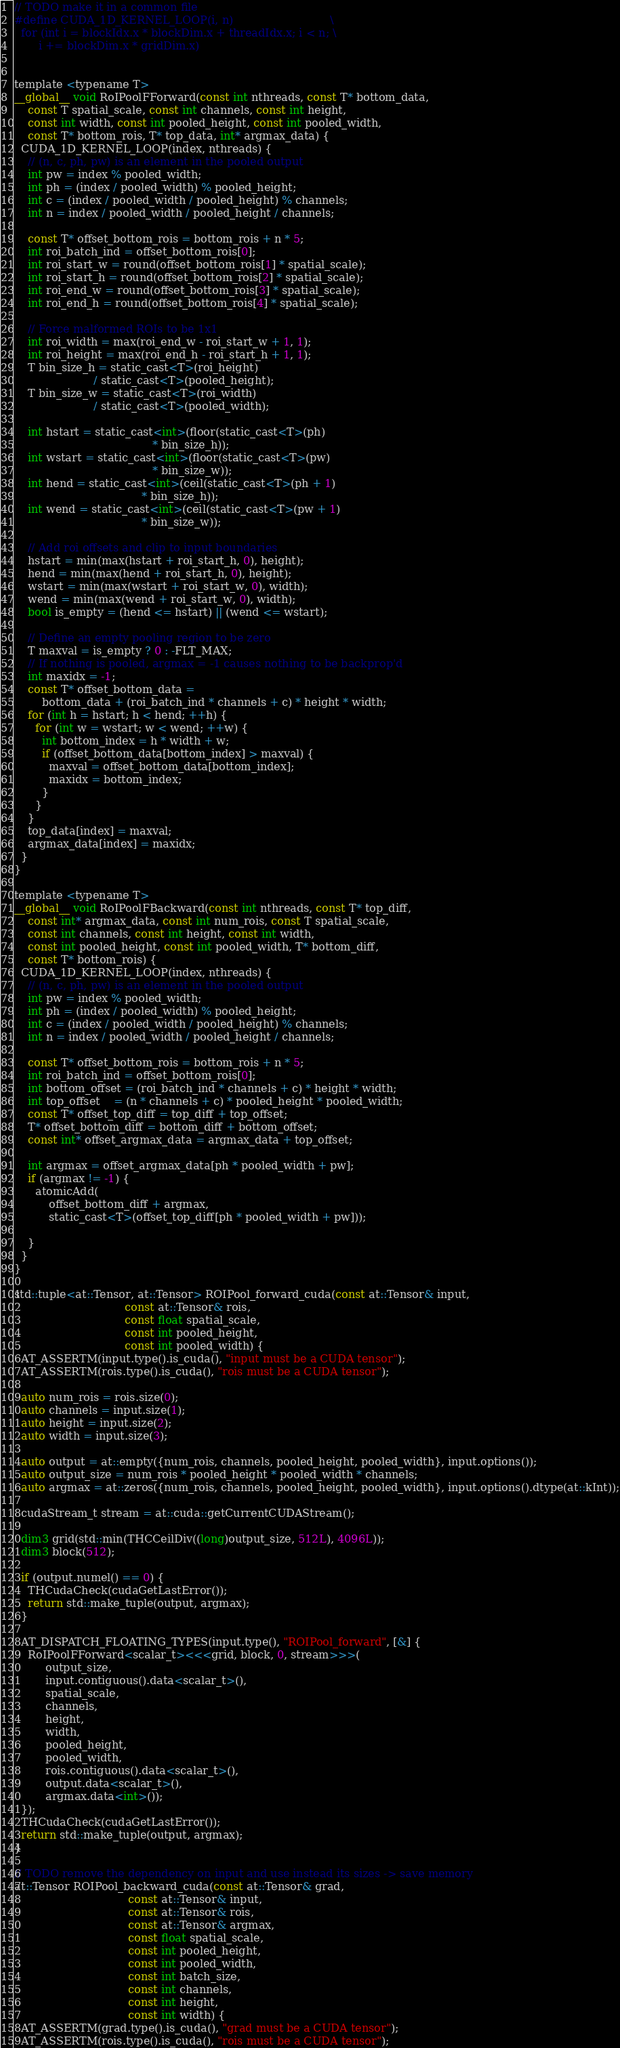Convert code to text. <code><loc_0><loc_0><loc_500><loc_500><_Cuda_>

// TODO make it in a common file
#define CUDA_1D_KERNEL_LOOP(i, n)                            \
  for (int i = blockIdx.x * blockDim.x + threadIdx.x; i < n; \
       i += blockDim.x * gridDim.x)


template <typename T>
__global__ void RoIPoolFForward(const int nthreads, const T* bottom_data,
    const T spatial_scale, const int channels, const int height,
    const int width, const int pooled_height, const int pooled_width,
    const T* bottom_rois, T* top_data, int* argmax_data) {
  CUDA_1D_KERNEL_LOOP(index, nthreads) {
    // (n, c, ph, pw) is an element in the pooled output
    int pw = index % pooled_width;
    int ph = (index / pooled_width) % pooled_height;
    int c = (index / pooled_width / pooled_height) % channels;
    int n = index / pooled_width / pooled_height / channels;

    const T* offset_bottom_rois = bottom_rois + n * 5;
    int roi_batch_ind = offset_bottom_rois[0];
    int roi_start_w = round(offset_bottom_rois[1] * spatial_scale);
    int roi_start_h = round(offset_bottom_rois[2] * spatial_scale);
    int roi_end_w = round(offset_bottom_rois[3] * spatial_scale);
    int roi_end_h = round(offset_bottom_rois[4] * spatial_scale);

    // Force malformed ROIs to be 1x1
    int roi_width = max(roi_end_w - roi_start_w + 1, 1);
    int roi_height = max(roi_end_h - roi_start_h + 1, 1);
    T bin_size_h = static_cast<T>(roi_height)
                       / static_cast<T>(pooled_height);
    T bin_size_w = static_cast<T>(roi_width)
                       / static_cast<T>(pooled_width);

    int hstart = static_cast<int>(floor(static_cast<T>(ph)
                                        * bin_size_h));
    int wstart = static_cast<int>(floor(static_cast<T>(pw)
                                        * bin_size_w));
    int hend = static_cast<int>(ceil(static_cast<T>(ph + 1)
                                     * bin_size_h));
    int wend = static_cast<int>(ceil(static_cast<T>(pw + 1)
                                     * bin_size_w));

    // Add roi offsets and clip to input boundaries
    hstart = min(max(hstart + roi_start_h, 0), height);
    hend = min(max(hend + roi_start_h, 0), height);
    wstart = min(max(wstart + roi_start_w, 0), width);
    wend = min(max(wend + roi_start_w, 0), width);
    bool is_empty = (hend <= hstart) || (wend <= wstart);

    // Define an empty pooling region to be zero
    T maxval = is_empty ? 0 : -FLT_MAX;
    // If nothing is pooled, argmax = -1 causes nothing to be backprop'd
    int maxidx = -1;
    const T* offset_bottom_data =
        bottom_data + (roi_batch_ind * channels + c) * height * width;
    for (int h = hstart; h < hend; ++h) {
      for (int w = wstart; w < wend; ++w) {
        int bottom_index = h * width + w;
        if (offset_bottom_data[bottom_index] > maxval) {
          maxval = offset_bottom_data[bottom_index];
          maxidx = bottom_index;
        }
      }
    }
    top_data[index] = maxval;
    argmax_data[index] = maxidx;
  }
}

template <typename T>
__global__ void RoIPoolFBackward(const int nthreads, const T* top_diff,
    const int* argmax_data, const int num_rois, const T spatial_scale,
    const int channels, const int height, const int width,
    const int pooled_height, const int pooled_width, T* bottom_diff,
    const T* bottom_rois) {
  CUDA_1D_KERNEL_LOOP(index, nthreads) {
    // (n, c, ph, pw) is an element in the pooled output
    int pw = index % pooled_width;
    int ph = (index / pooled_width) % pooled_height;
    int c = (index / pooled_width / pooled_height) % channels;
    int n = index / pooled_width / pooled_height / channels;

    const T* offset_bottom_rois = bottom_rois + n * 5;
    int roi_batch_ind = offset_bottom_rois[0];
    int bottom_offset = (roi_batch_ind * channels + c) * height * width;
    int top_offset    = (n * channels + c) * pooled_height * pooled_width;
    const T* offset_top_diff = top_diff + top_offset;
    T* offset_bottom_diff = bottom_diff + bottom_offset;
    const int* offset_argmax_data = argmax_data + top_offset;

    int argmax = offset_argmax_data[ph * pooled_width + pw];
    if (argmax != -1) {
      atomicAdd(
          offset_bottom_diff + argmax,
          static_cast<T>(offset_top_diff[ph * pooled_width + pw]));

    }
  }
}

std::tuple<at::Tensor, at::Tensor> ROIPool_forward_cuda(const at::Tensor& input,
                                const at::Tensor& rois,
                                const float spatial_scale,
                                const int pooled_height,
                                const int pooled_width) {
  AT_ASSERTM(input.type().is_cuda(), "input must be a CUDA tensor");
  AT_ASSERTM(rois.type().is_cuda(), "rois must be a CUDA tensor");

  auto num_rois = rois.size(0);
  auto channels = input.size(1);
  auto height = input.size(2);
  auto width = input.size(3);

  auto output = at::empty({num_rois, channels, pooled_height, pooled_width}, input.options());
  auto output_size = num_rois * pooled_height * pooled_width * channels;
  auto argmax = at::zeros({num_rois, channels, pooled_height, pooled_width}, input.options().dtype(at::kInt));

  cudaStream_t stream = at::cuda::getCurrentCUDAStream();

  dim3 grid(std::min(THCCeilDiv((long)output_size, 512L), 4096L));
  dim3 block(512);

  if (output.numel() == 0) {
    THCudaCheck(cudaGetLastError());
    return std::make_tuple(output, argmax);
  }

  AT_DISPATCH_FLOATING_TYPES(input.type(), "ROIPool_forward", [&] {
    RoIPoolFForward<scalar_t><<<grid, block, 0, stream>>>(
         output_size,
         input.contiguous().data<scalar_t>(),
         spatial_scale,
         channels,
         height,
         width,
         pooled_height,
         pooled_width,
         rois.contiguous().data<scalar_t>(),
         output.data<scalar_t>(),
         argmax.data<int>());
  });
  THCudaCheck(cudaGetLastError());
  return std::make_tuple(output, argmax);
}

// TODO remove the dependency on input and use instead its sizes -> save memory
at::Tensor ROIPool_backward_cuda(const at::Tensor& grad,
                                 const at::Tensor& input,
                                 const at::Tensor& rois,
                                 const at::Tensor& argmax,
                                 const float spatial_scale,
                                 const int pooled_height,
                                 const int pooled_width,
                                 const int batch_size,
                                 const int channels,
                                 const int height,
                                 const int width) {
  AT_ASSERTM(grad.type().is_cuda(), "grad must be a CUDA tensor");
  AT_ASSERTM(rois.type().is_cuda(), "rois must be a CUDA tensor");</code> 